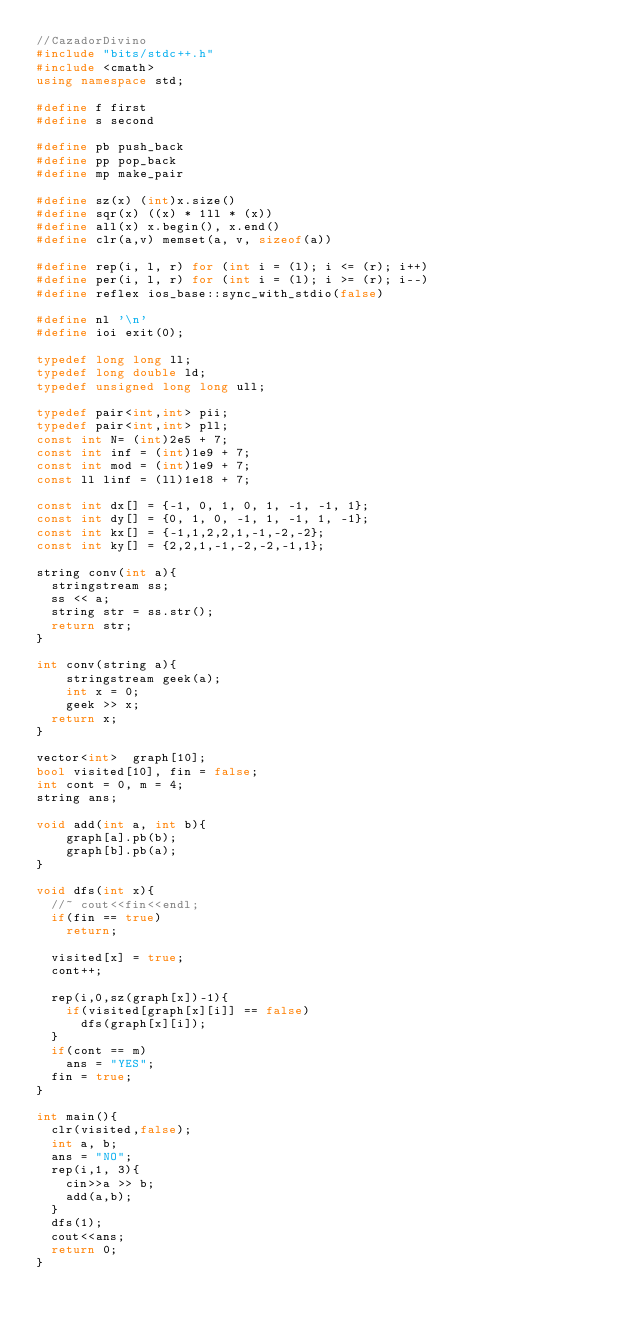Convert code to text. <code><loc_0><loc_0><loc_500><loc_500><_C++_>//CazadorDivino
#include "bits/stdc++.h"
#include <cmath>
using namespace std;

#define f first
#define s second

#define pb push_back
#define pp pop_back
#define mp make_pair

#define sz(x) (int)x.size()
#define sqr(x) ((x) * 1ll * (x))
#define all(x) x.begin(), x.end()
#define clr(a,v) memset(a, v, sizeof(a))

#define rep(i, l, r) for (int i = (l); i <= (r); i++)
#define per(i, l, r) for (int i = (l); i >= (r); i--)
#define reflex ios_base::sync_with_stdio(false)

#define nl '\n'
#define ioi exit(0);

typedef long long ll;
typedef long double ld;
typedef unsigned long long ull;

typedef pair<int,int> pii;
typedef pair<int,int> pll;
const int N= (int)2e5 + 7;
const int inf = (int)1e9 + 7;
const int mod = (int)1e9 + 7;
const ll linf = (ll)1e18 + 7;

const int dx[] = {-1, 0, 1, 0, 1, -1, -1, 1};
const int dy[] = {0, 1, 0, -1, 1, -1, 1, -1};
const int kx[] = {-1,1,2,2,1,-1,-2,-2};
const int ky[] = {2,2,1,-1,-2,-2,-1,1};

string conv(int a){
	stringstream ss;
	ss << a;
	string str = ss.str();
	return str;
}

int conv(string a){
    stringstream geek(a); 
    int x = 0; 
    geek >> x;   
	return x;
}

vector<int>  graph[10];
bool visited[10], fin = false;
int cont = 0, m = 4;
string ans;

void add(int a, int b){
    graph[a].pb(b);
    graph[b].pb(a);
}

void dfs(int x){
	//~ cout<<fin<<endl;
	if(fin == true)
		return;
		
	visited[x] = true;
	cont++;
	
	rep(i,0,sz(graph[x])-1){
		if(visited[graph[x][i]] == false)
			dfs(graph[x][i]);
	}
	if(cont == m)
		ans = "YES";
	fin = true;
}

int main(){
	clr(visited,false);
	int a, b;
	ans = "NO";
	rep(i,1, 3){
		cin>>a >> b;
		add(a,b);
	}
	dfs(1);
	cout<<ans;
	return 0;
}
</code> 